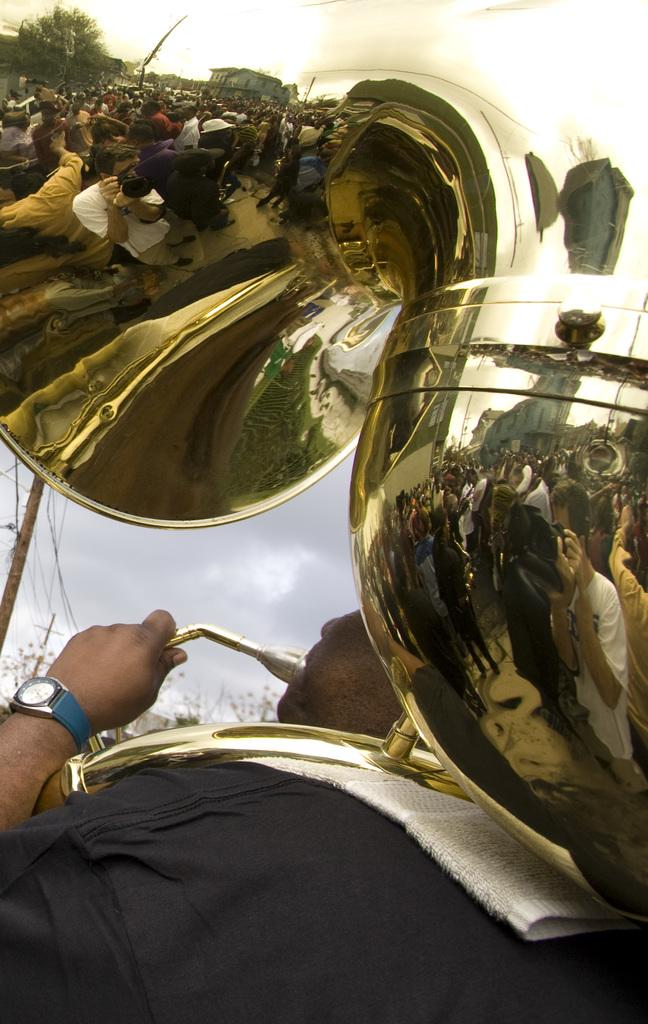Who is present in the image? There is a man in the image. What is the man holding in the image? The man is holding a musical instrument. What can be seen in the background of the image? The sky is visible in the image. What is the size of the beam in the image? There is no beam present in the image. 